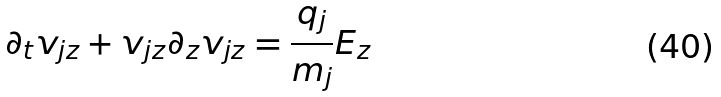<formula> <loc_0><loc_0><loc_500><loc_500>\partial _ { t } v _ { j z } + v _ { j z } \partial _ { z } v _ { j z } = \frac { q _ { j } } { m _ { j } } E _ { z }</formula> 